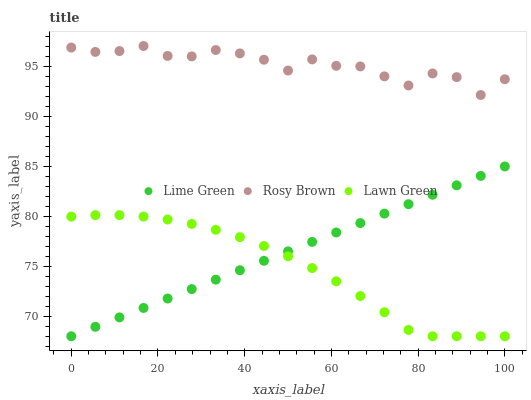Does Lawn Green have the minimum area under the curve?
Answer yes or no. Yes. Does Rosy Brown have the maximum area under the curve?
Answer yes or no. Yes. Does Lime Green have the minimum area under the curve?
Answer yes or no. No. Does Lime Green have the maximum area under the curve?
Answer yes or no. No. Is Lime Green the smoothest?
Answer yes or no. Yes. Is Rosy Brown the roughest?
Answer yes or no. Yes. Is Rosy Brown the smoothest?
Answer yes or no. No. Is Lime Green the roughest?
Answer yes or no. No. Does Lawn Green have the lowest value?
Answer yes or no. Yes. Does Rosy Brown have the lowest value?
Answer yes or no. No. Does Rosy Brown have the highest value?
Answer yes or no. Yes. Does Lime Green have the highest value?
Answer yes or no. No. Is Lawn Green less than Rosy Brown?
Answer yes or no. Yes. Is Rosy Brown greater than Lime Green?
Answer yes or no. Yes. Does Lawn Green intersect Lime Green?
Answer yes or no. Yes. Is Lawn Green less than Lime Green?
Answer yes or no. No. Is Lawn Green greater than Lime Green?
Answer yes or no. No. Does Lawn Green intersect Rosy Brown?
Answer yes or no. No. 